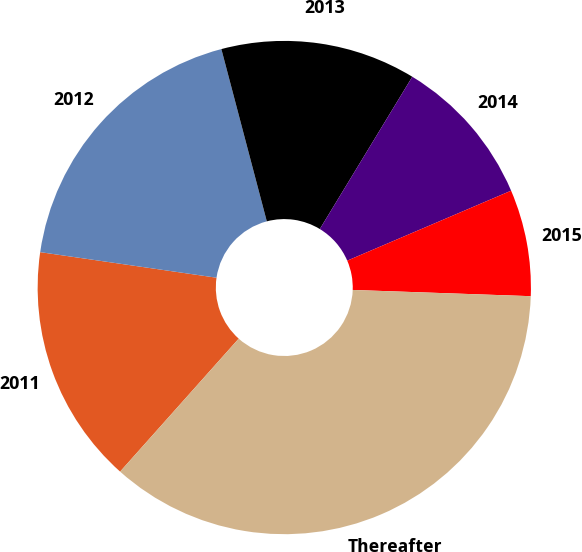Convert chart. <chart><loc_0><loc_0><loc_500><loc_500><pie_chart><fcel>2011<fcel>2012<fcel>2013<fcel>2014<fcel>2015<fcel>Thereafter<nl><fcel>15.7%<fcel>18.6%<fcel>12.79%<fcel>9.89%<fcel>6.98%<fcel>36.03%<nl></chart> 